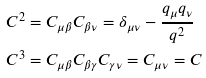Convert formula to latex. <formula><loc_0><loc_0><loc_500><loc_500>C ^ { 2 } & = C _ { \mu \beta } C _ { \beta \nu } = \delta _ { \mu \nu } - \frac { q _ { \mu } q _ { \nu } } { q ^ { 2 } } \\ C ^ { 3 } & = C _ { \mu \beta } C _ { \beta \gamma } C _ { \gamma \nu } = C _ { \mu \nu } = C</formula> 